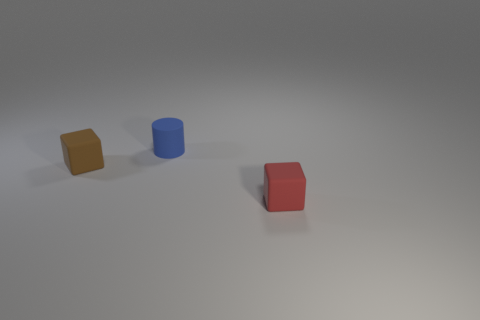Add 1 tiny red blocks. How many objects exist? 4 Subtract all cylinders. How many objects are left? 2 Subtract 0 cyan cylinders. How many objects are left? 3 Subtract all yellow matte objects. Subtract all small blocks. How many objects are left? 1 Add 1 small cylinders. How many small cylinders are left? 2 Add 3 blue cylinders. How many blue cylinders exist? 4 